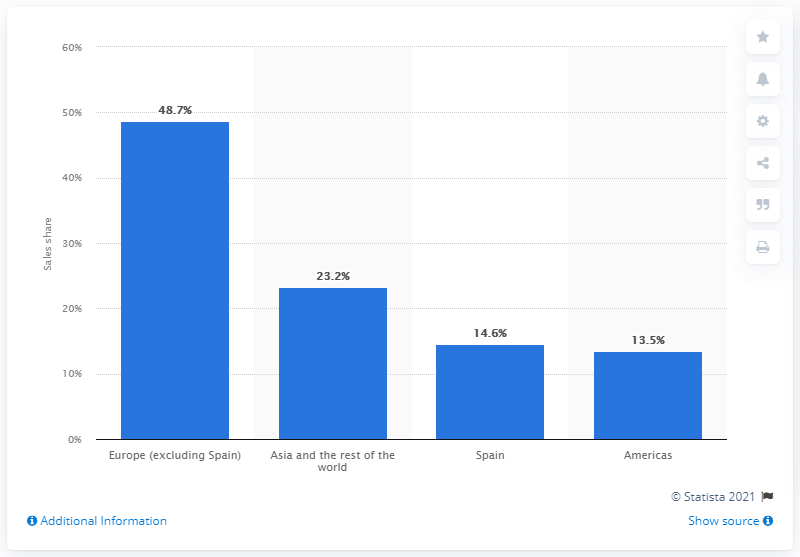Mention a couple of crucial points in this snapshot. In 2020, 23.2% of Inditex Group's sales were generated from Asia and the rest of the world. 